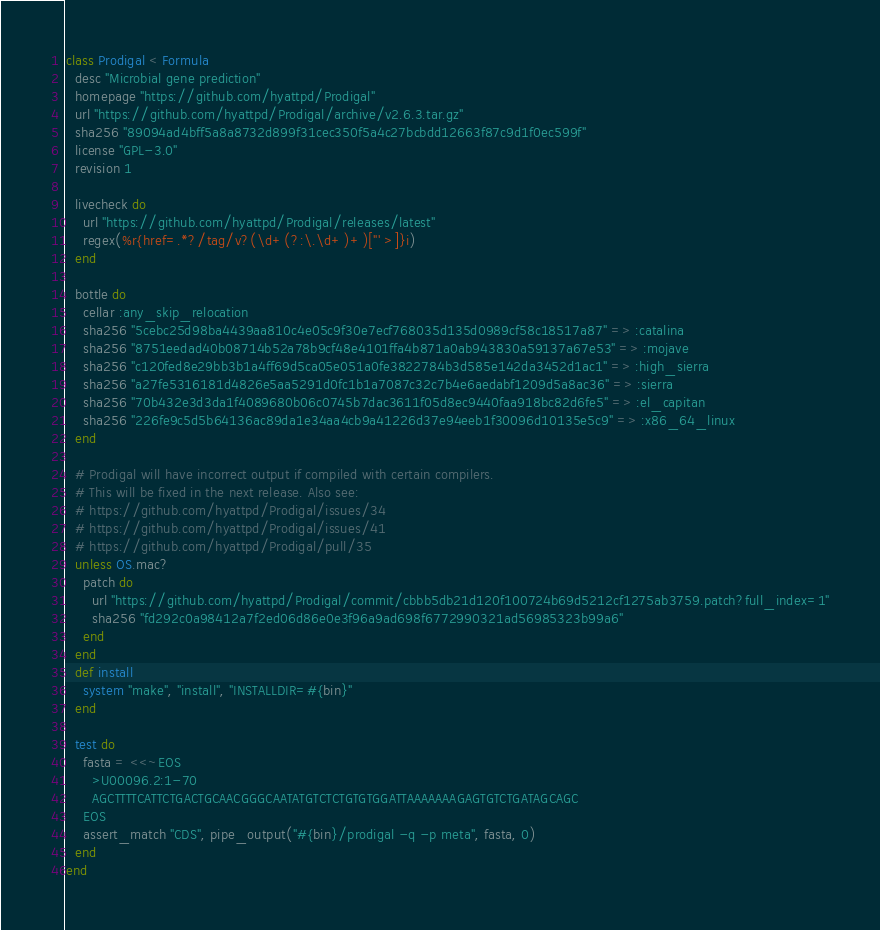<code> <loc_0><loc_0><loc_500><loc_500><_Ruby_>class Prodigal < Formula
  desc "Microbial gene prediction"
  homepage "https://github.com/hyattpd/Prodigal"
  url "https://github.com/hyattpd/Prodigal/archive/v2.6.3.tar.gz"
  sha256 "89094ad4bff5a8a8732d899f31cec350f5a4c27bcbdd12663f87c9d1f0ec599f"
  license "GPL-3.0"
  revision 1

  livecheck do
    url "https://github.com/hyattpd/Prodigal/releases/latest"
    regex(%r{href=.*?/tag/v?(\d+(?:\.\d+)+)["' >]}i)
  end

  bottle do
    cellar :any_skip_relocation
    sha256 "5cebc25d98ba4439aa810c4e05c9f30e7ecf768035d135d0989cf58c18517a87" => :catalina
    sha256 "8751eedad40b08714b52a78b9cf48e4101ffa4b871a0ab943830a59137a67e53" => :mojave
    sha256 "c120fed8e29bb3b1a4ff69d5ca05e051a0fe3822784b3d585e142da3452d1ac1" => :high_sierra
    sha256 "a27fe5316181d4826e5aa5291d0fc1b1a7087c32c7b4e6aedabf1209d5a8ac36" => :sierra
    sha256 "70b432e3d3da1f4089680b06c0745b7dac3611f05d8ec9440faa918bc82d6fe5" => :el_capitan
    sha256 "226fe9c5d5b64136ac89da1e34aa4cb9a41226d37e94eeb1f30096d10135e5c9" => :x86_64_linux
  end

  # Prodigal will have incorrect output if compiled with certain compilers.
  # This will be fixed in the next release. Also see:
  # https://github.com/hyattpd/Prodigal/issues/34
  # https://github.com/hyattpd/Prodigal/issues/41
  # https://github.com/hyattpd/Prodigal/pull/35
  unless OS.mac?
    patch do
      url "https://github.com/hyattpd/Prodigal/commit/cbbb5db21d120f100724b69d5212cf1275ab3759.patch?full_index=1"
      sha256 "fd292c0a98412a7f2ed06d86e0e3f96a9ad698f6772990321ad56985323b99a6"
    end
  end
  def install
    system "make", "install", "INSTALLDIR=#{bin}"
  end

  test do
    fasta = <<~EOS
      >U00096.2:1-70
      AGCTTTTCATTCTGACTGCAACGGGCAATATGTCTCTGTGTGGATTAAAAAAAGAGTGTCTGATAGCAGC
    EOS
    assert_match "CDS", pipe_output("#{bin}/prodigal -q -p meta", fasta, 0)
  end
end
</code> 